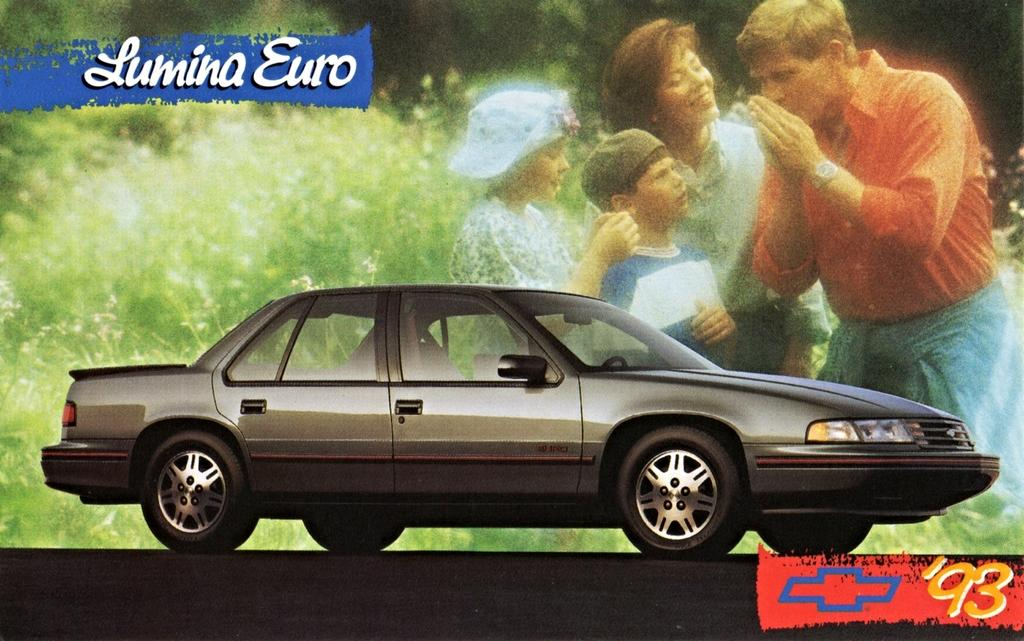What is the main subject of the image? The main subject of the image is a car. What is visible behind the car in the image? There is a projector display behind the car. What type of bone can be seen in the image? There is no bone present in the image; it features a car and a projector display. 